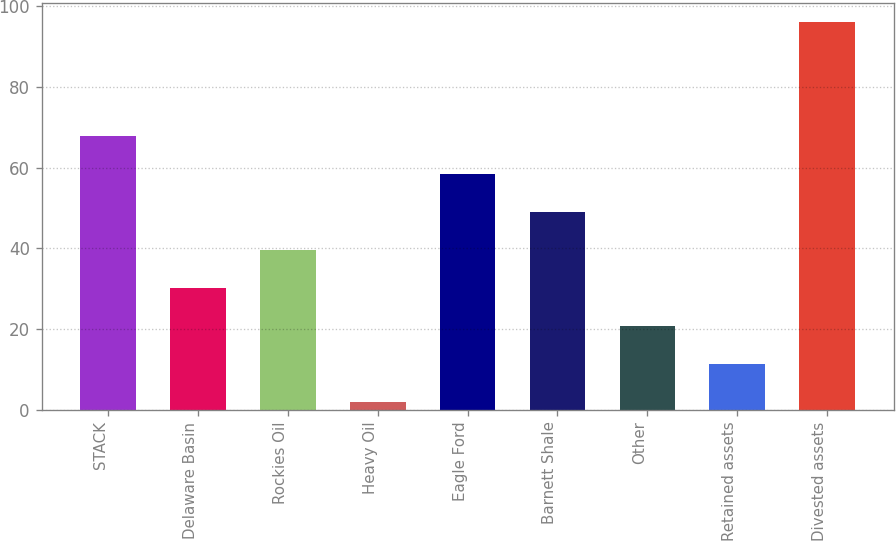Convert chart. <chart><loc_0><loc_0><loc_500><loc_500><bar_chart><fcel>STACK<fcel>Delaware Basin<fcel>Rockies Oil<fcel>Heavy Oil<fcel>Eagle Ford<fcel>Barnett Shale<fcel>Other<fcel>Retained assets<fcel>Divested assets<nl><fcel>67.8<fcel>30.2<fcel>39.6<fcel>2<fcel>58.4<fcel>49<fcel>20.8<fcel>11.4<fcel>96<nl></chart> 